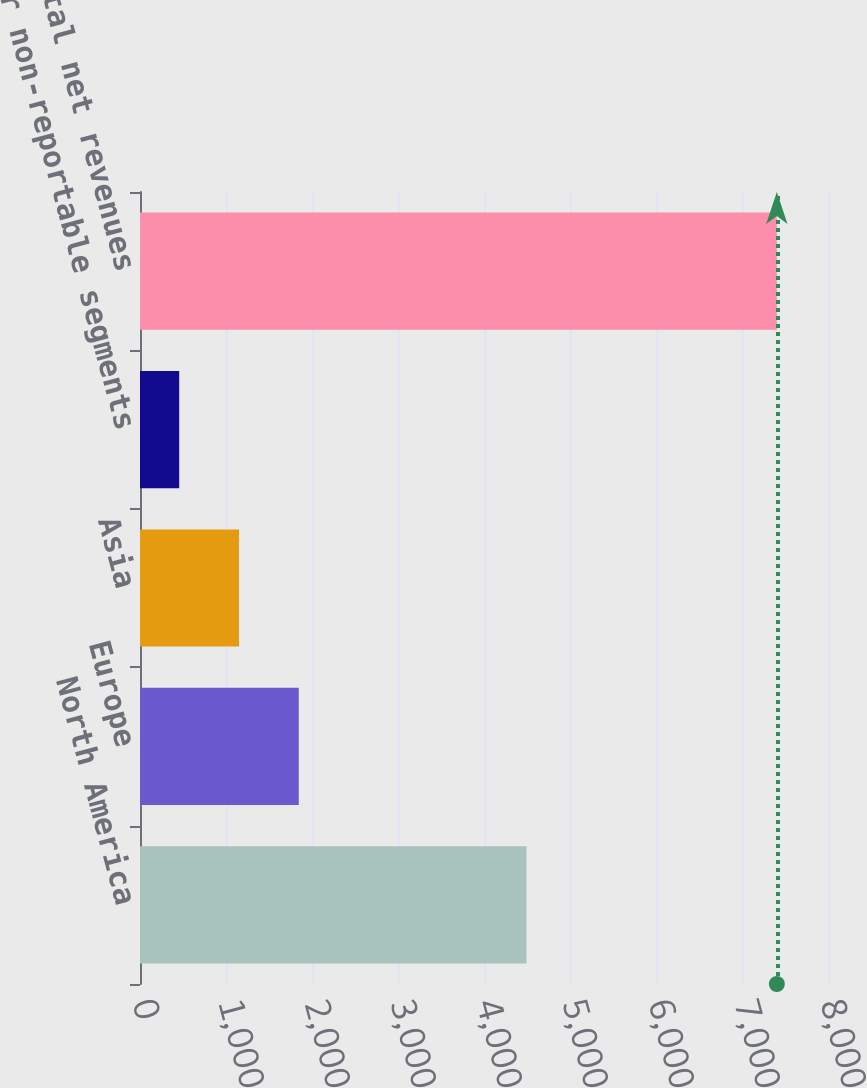Convert chart. <chart><loc_0><loc_0><loc_500><loc_500><bar_chart><fcel>North America<fcel>Europe<fcel>Asia<fcel>Other non-reportable segments<fcel>Total net revenues<nl><fcel>4493.9<fcel>1845.84<fcel>1150.92<fcel>456<fcel>7405.2<nl></chart> 